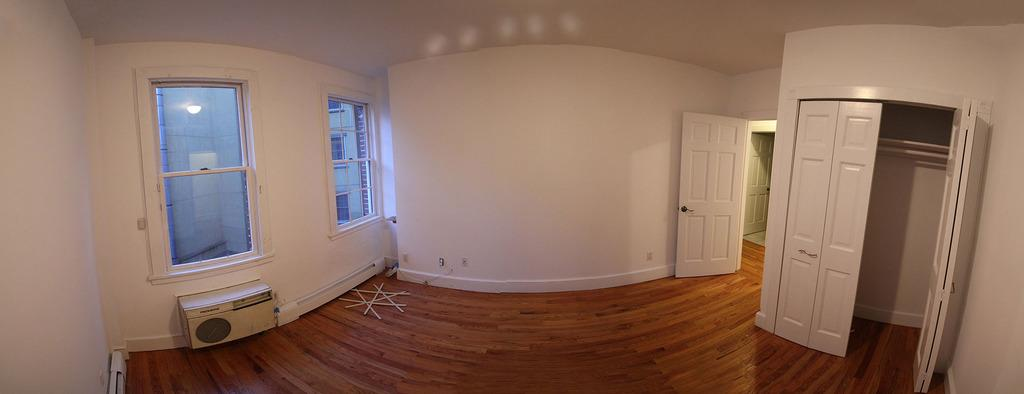Where was the image taken? The image was taken inside a room. What can be found on the right side of the room? There are doors on the right side of the room. What feature is located in the middle of the room? There are windows in the middle of the room. What is the source of light in the room? There is light in the middle of the room. What type of soup is being served in the room? There is no soup present in the image, as it is focused on the doors, windows, and light source in the room. 